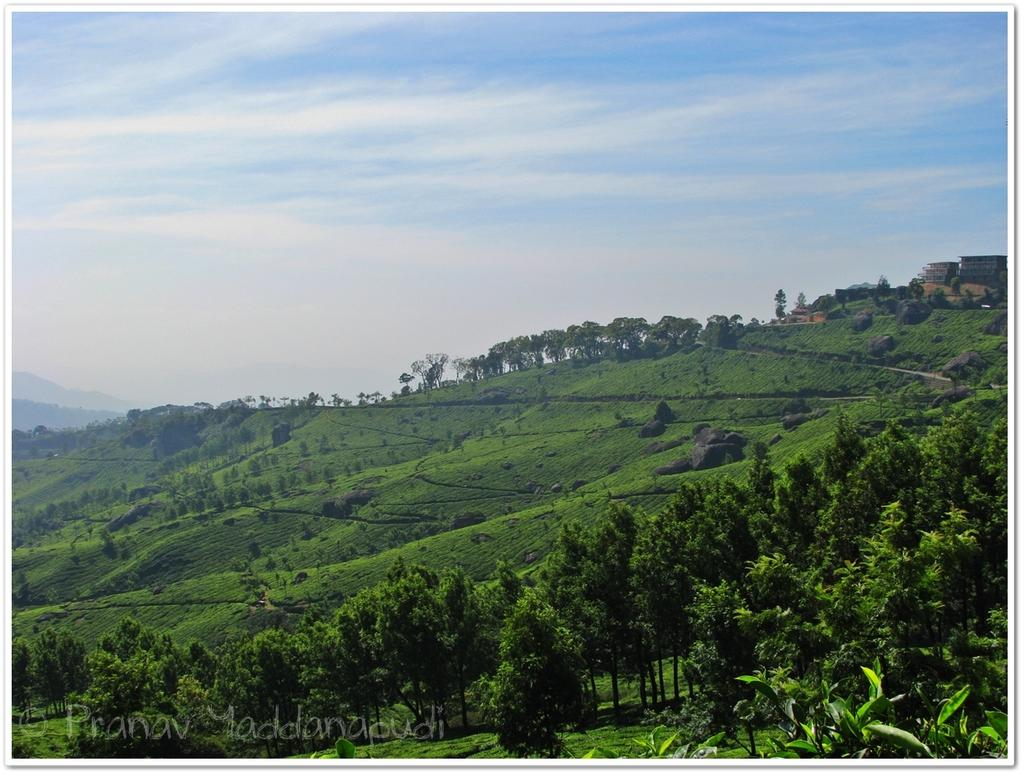What is the possible location from where the image was taken? The image might be taken from outside of the city. What type of vegetation can be seen in the image? There are trees and plants in the image. What geographical feature is visible in the image? There are mountains in the image. What is visible at the top of the image? The sky is visible at the top of the image. How many cubs are playing with the boys in the image? There are no cubs or boys present in the image. What level of experience does the beginner have in the image? There is no indication of any experience level or activity involving a beginner in the image. 